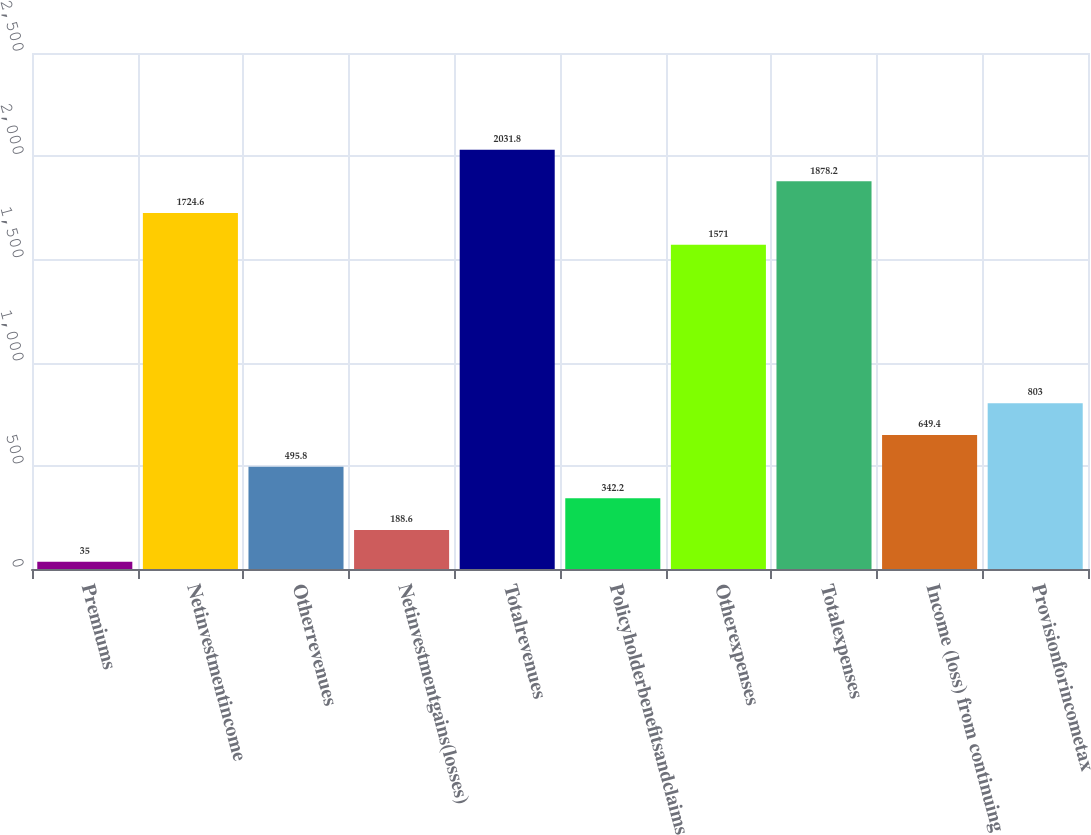Convert chart to OTSL. <chart><loc_0><loc_0><loc_500><loc_500><bar_chart><fcel>Premiums<fcel>Netinvestmentincome<fcel>Otherrevenues<fcel>Netinvestmentgains(losses)<fcel>Totalrevenues<fcel>Policyholderbenefitsandclaims<fcel>Otherexpenses<fcel>Totalexpenses<fcel>Income (loss) from continuing<fcel>Provisionforincometax<nl><fcel>35<fcel>1724.6<fcel>495.8<fcel>188.6<fcel>2031.8<fcel>342.2<fcel>1571<fcel>1878.2<fcel>649.4<fcel>803<nl></chart> 